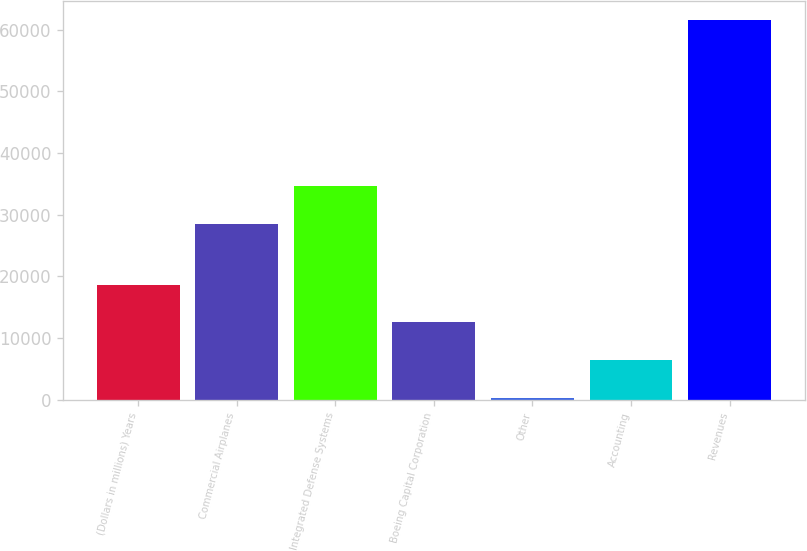Convert chart to OTSL. <chart><loc_0><loc_0><loc_500><loc_500><bar_chart><fcel>(Dollars in millions) Years<fcel>Commercial Airplanes<fcel>Integrated Defense Systems<fcel>Boeing Capital Corporation<fcel>Other<fcel>Accounting<fcel>Revenues<nl><fcel>18668.3<fcel>28465<fcel>34588.1<fcel>12545.2<fcel>299<fcel>6422.1<fcel>61530<nl></chart> 